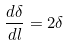<formula> <loc_0><loc_0><loc_500><loc_500>\frac { d \delta } { d l } = 2 \delta</formula> 